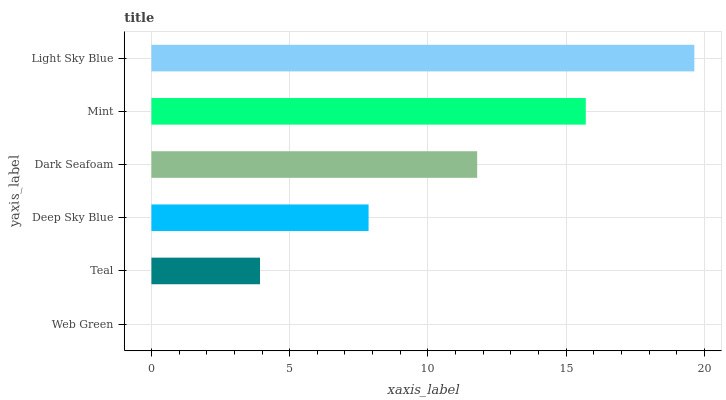Is Web Green the minimum?
Answer yes or no. Yes. Is Light Sky Blue the maximum?
Answer yes or no. Yes. Is Teal the minimum?
Answer yes or no. No. Is Teal the maximum?
Answer yes or no. No. Is Teal greater than Web Green?
Answer yes or no. Yes. Is Web Green less than Teal?
Answer yes or no. Yes. Is Web Green greater than Teal?
Answer yes or no. No. Is Teal less than Web Green?
Answer yes or no. No. Is Dark Seafoam the high median?
Answer yes or no. Yes. Is Deep Sky Blue the low median?
Answer yes or no. Yes. Is Deep Sky Blue the high median?
Answer yes or no. No. Is Web Green the low median?
Answer yes or no. No. 